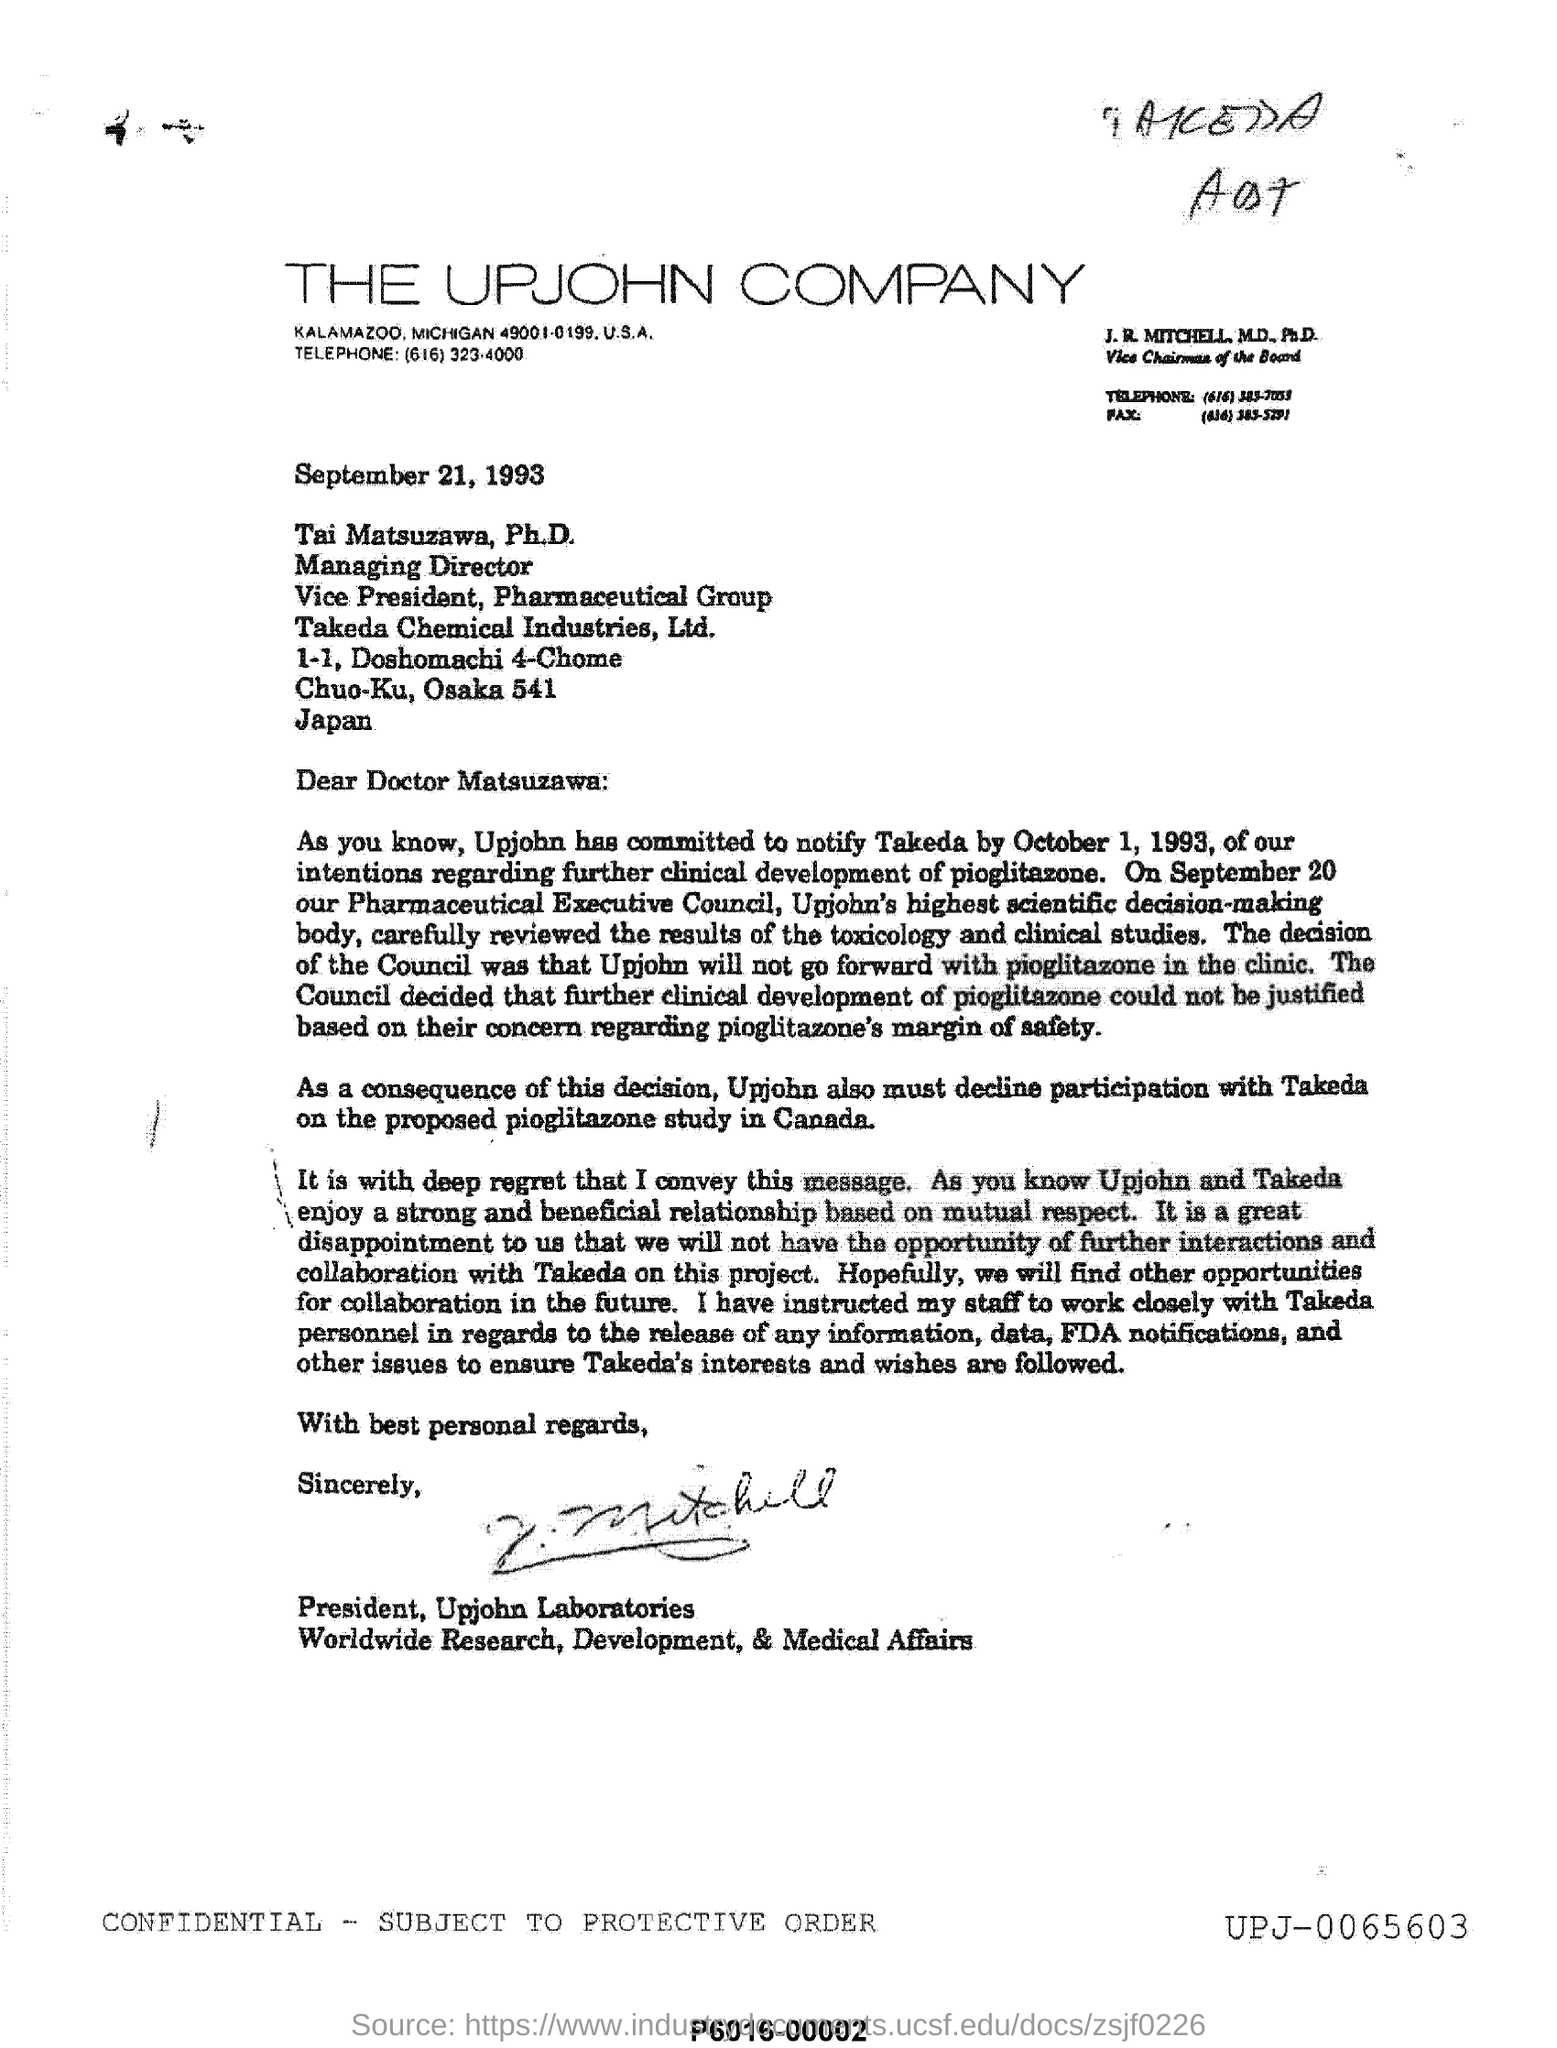Give some essential details in this illustration. The Upjohn Company is located in the United States of America. The Upjohn Company" is the name of the company. The letterhead mentions THE UPJOHN COMPANY. On September 21, 1993, the date and year were mentioned. 